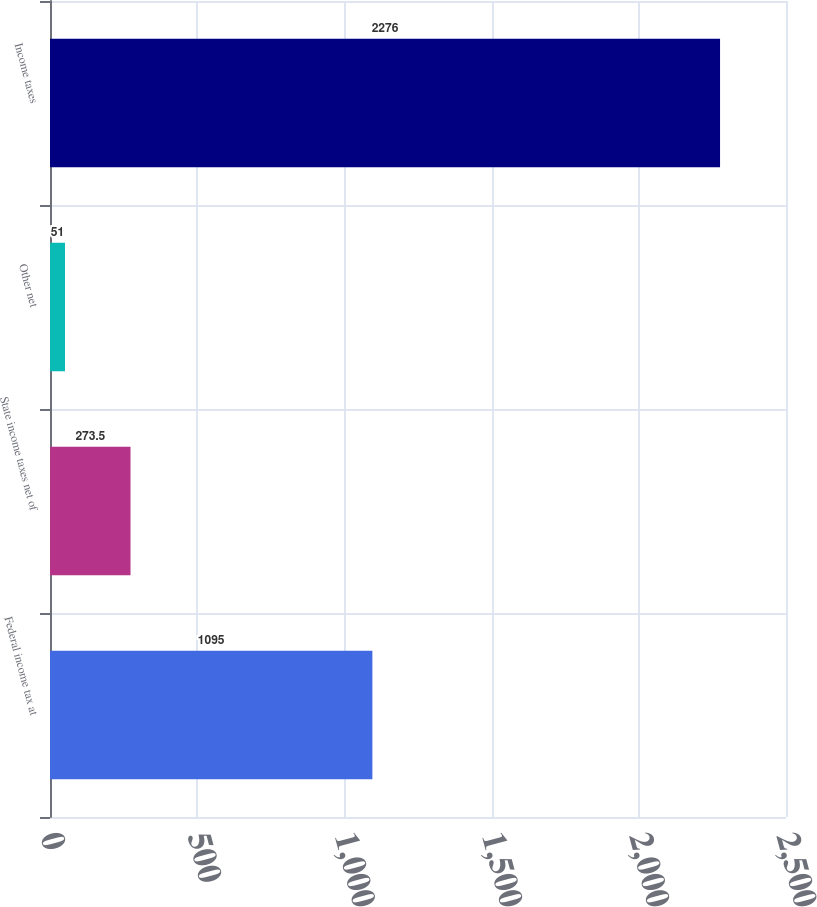Convert chart to OTSL. <chart><loc_0><loc_0><loc_500><loc_500><bar_chart><fcel>Federal income tax at<fcel>State income taxes net of<fcel>Other net<fcel>Income taxes<nl><fcel>1095<fcel>273.5<fcel>51<fcel>2276<nl></chart> 